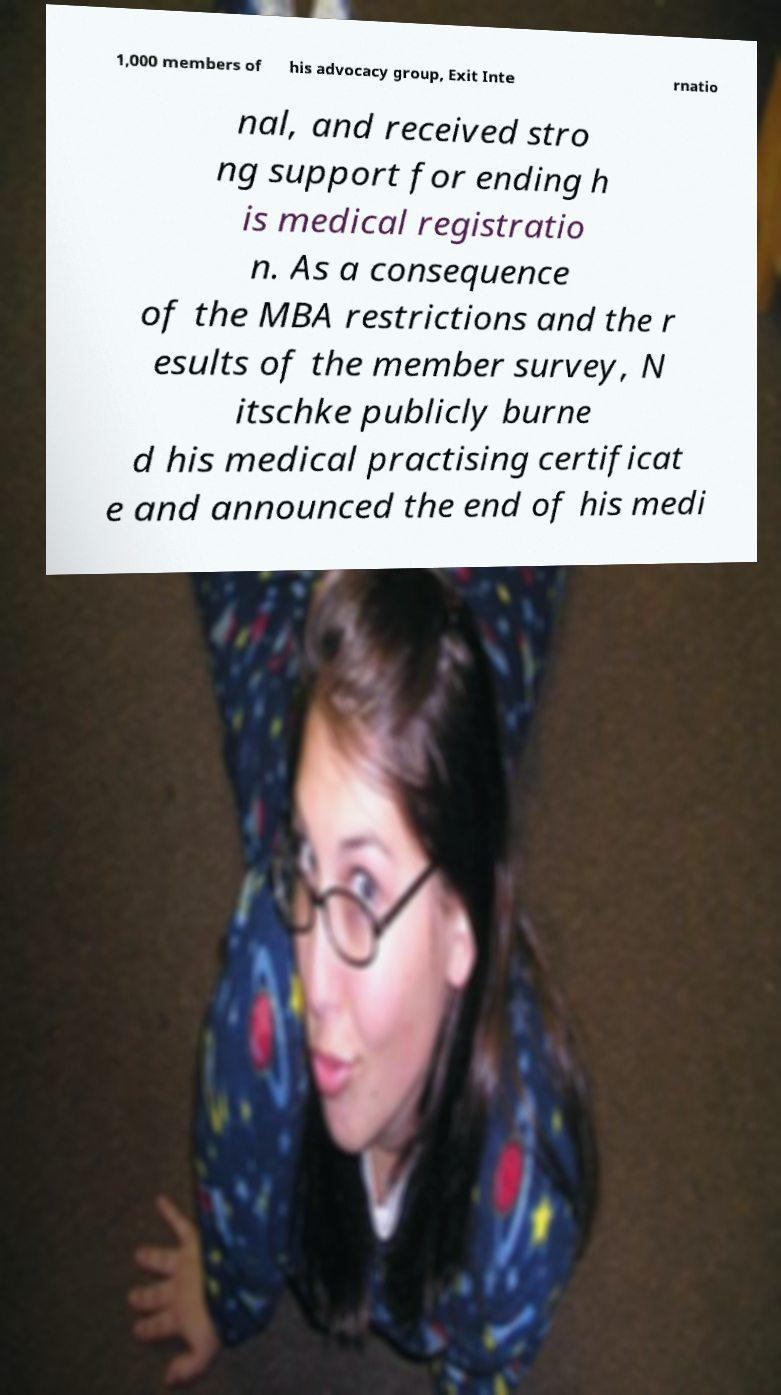Can you accurately transcribe the text from the provided image for me? 1,000 members of his advocacy group, Exit Inte rnatio nal, and received stro ng support for ending h is medical registratio n. As a consequence of the MBA restrictions and the r esults of the member survey, N itschke publicly burne d his medical practising certificat e and announced the end of his medi 